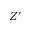Convert formula to latex. <formula><loc_0><loc_0><loc_500><loc_500>Z ^ { \prime }</formula> 